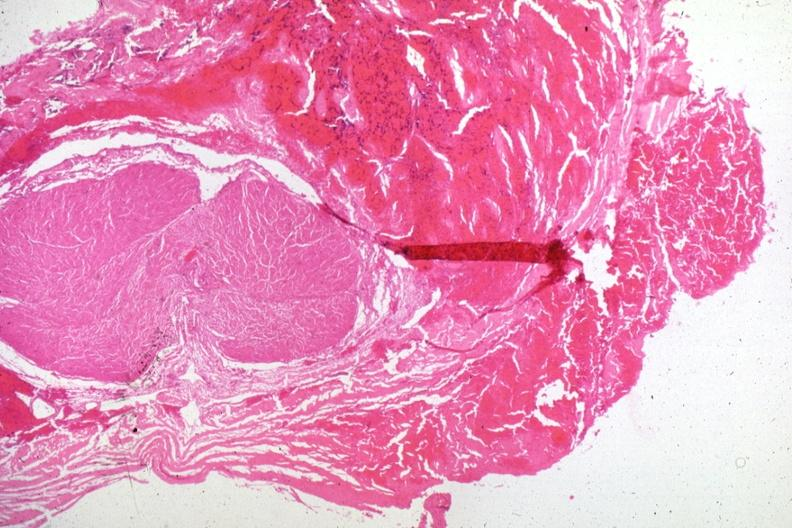s malignant adenoma present?
Answer the question using a single word or phrase. Yes 